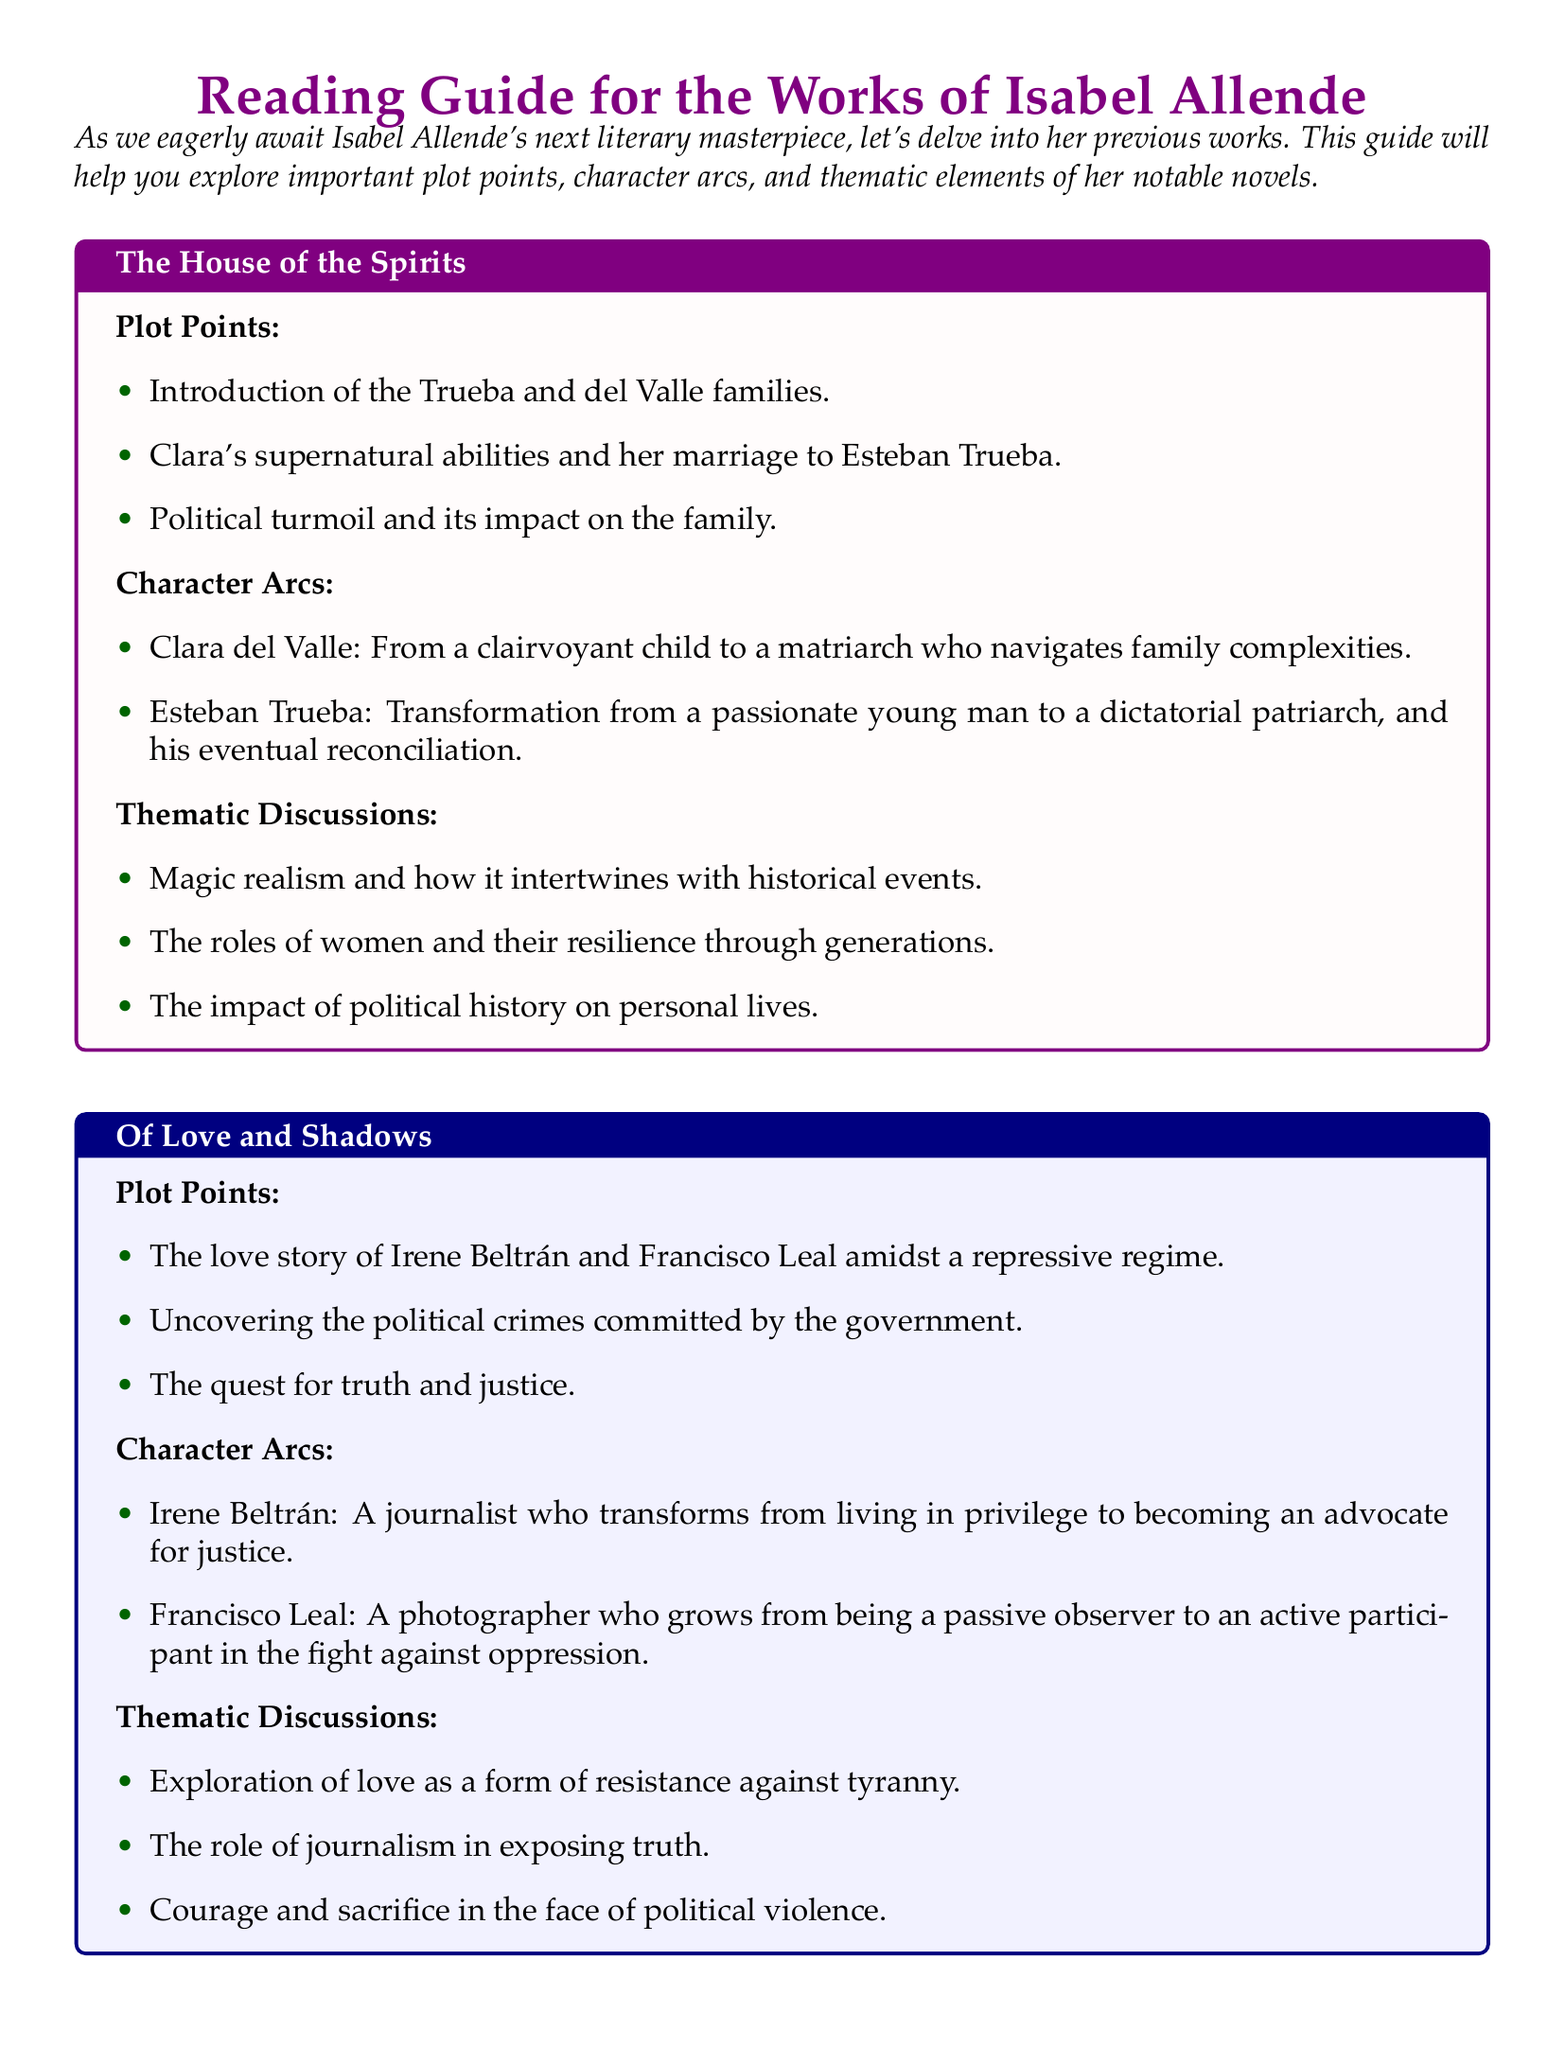What is the title of the reading guide? The title specified at the top of the document is "Reading Guide for the Works of Isabel Allende."
Answer: Reading Guide for the Works of Isabel Allende Which novel features Clara del Valle as a character? Clara del Valle is mentioned under "The House of the Spirits," which is one of the novels discussed.
Answer: The House of the Spirits What key theme is discussed in "Daughter of Fortune"? The thematic discussions for "Daughter of Fortune" include the immigrant experience and cultural assimilation, which indicates focus areas within the novel.
Answer: The immigrant experience and cultural assimilation How does Esteban Trueba's character evolve? The character arc for Esteban Trueba describes his transformation from a passionate young man to a dictatorial patriarch.
Answer: From a passionate young man to a dictatorial patriarch What is the primary setting for Eliza Sommers' journey? The document identifies Eliza Sommers' journey as taking place from Valparaíso to California during the Gold Rush.
Answer: From Valparaíso to California Name a form of resistance discussed in "Of Love and Shadows." The thematic discussions highlight love as a form of resistance against tyranny, showing how relationships can oppose oppressive forces.
Answer: Love as a form of resistance against tyranny Which character undergoes significant growth in "Daughter of Fortune"? Eliza Sommers is identified as the character who grows from a sheltered girl into an independent woman.
Answer: Eliza Sommers What color is used for the title section of "Of Love and Shadows"? The color used for the title of "Of Love and Shadows" is blue, as indicated by the document formatting.
Answer: Blue 